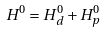<formula> <loc_0><loc_0><loc_500><loc_500>H ^ { 0 } = H ^ { 0 } _ { d } + H ^ { 0 } _ { p }</formula> 